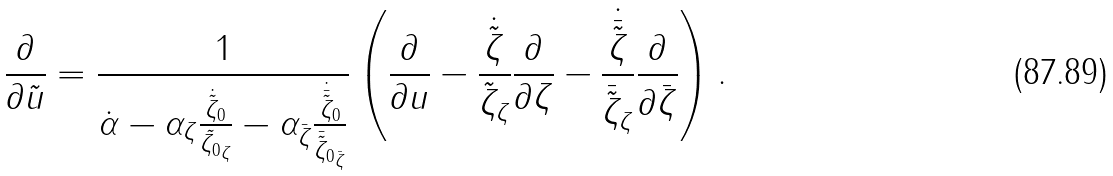Convert formula to latex. <formula><loc_0><loc_0><loc_500><loc_500>\frac { \partial } { \partial \tilde { u } } = \frac { 1 } { \dot { \alpha } - \alpha _ { \zeta } \frac { \dot { \tilde { \zeta } } _ { 0 } } { \tilde { \zeta _ { 0 } } _ { \zeta } } - \alpha _ { \bar { \zeta } } \frac { \dot { \bar { \tilde { \zeta } } } _ { 0 } } { { \bar { \tilde { \zeta } } _ { 0 } } _ { \bar { \zeta } } } } \left ( \frac { \partial } { \partial u } - \frac { \dot { \tilde { \zeta } } } { \tilde { \zeta } _ { \zeta } } \frac { \partial } { \partial \zeta } - \frac { \dot { \bar { \tilde { \zeta } } } } { \bar { \tilde { \zeta } } _ { \zeta } } \frac { \partial } { \partial \bar { \zeta } } \right ) .</formula> 